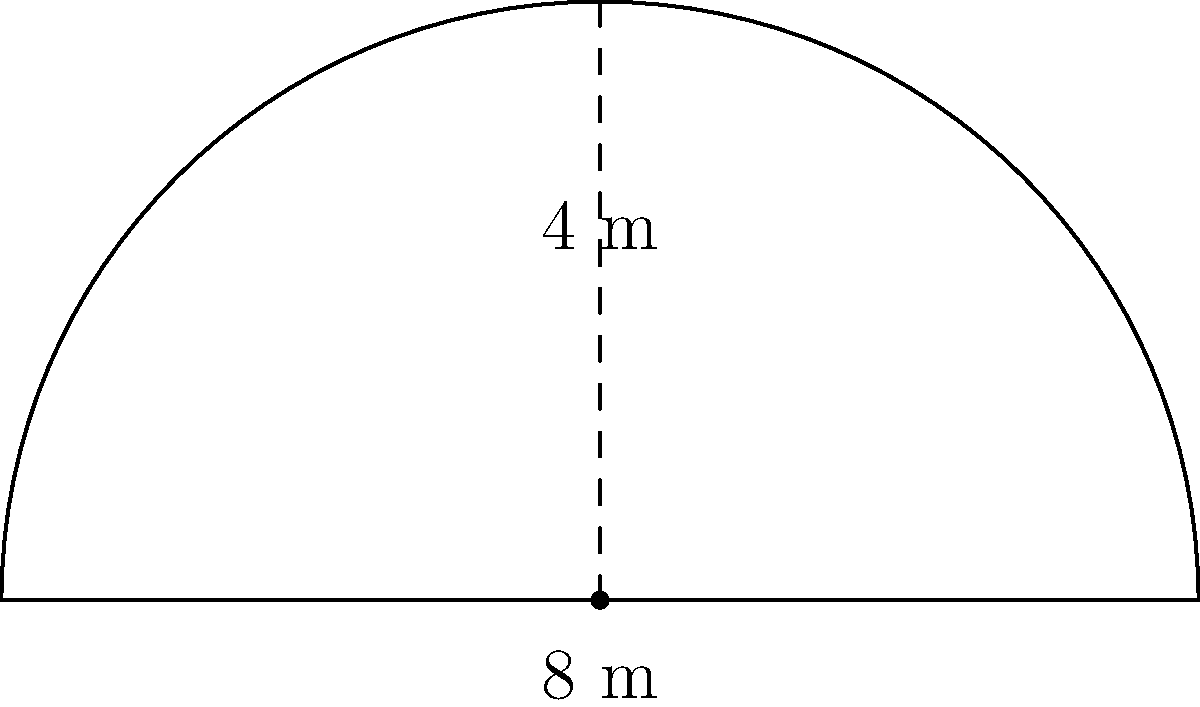As a satirical journalist, you've been assigned to cover a comedy show at the "Lachhaus" club in Berlin. The stage has a unique semicircular front, as shown in the diagram. If the straight edge at the back of the stage is 8 meters long and the radius of the semicircle is 4 meters, what is the perimeter of the entire stage in meters? Let's approach this step-by-step:

1) The stage consists of two parts: a straight line and a semicircle.

2) We're given that the straight line (back of the stage) is 8 meters long.

3) For the semicircle:
   - The radius is 4 meters
   - The formula for the length of a semicircle is $\pi r$, where $r$ is the radius

4) Calculate the length of the semicircle:
   $\text{Length of semicircle} = \pi \cdot 4 = 4\pi$ meters

5) The perimeter is the sum of the straight line and the semicircle:
   $\text{Perimeter} = 8 + 4\pi$ meters

6) If we want to calculate the exact value:
   $8 + 4\pi \approx 20.57$ meters

However, leaving the answer in terms of $\pi$ is often preferred in mathematical contexts.
Answer: $8 + 4\pi$ meters 